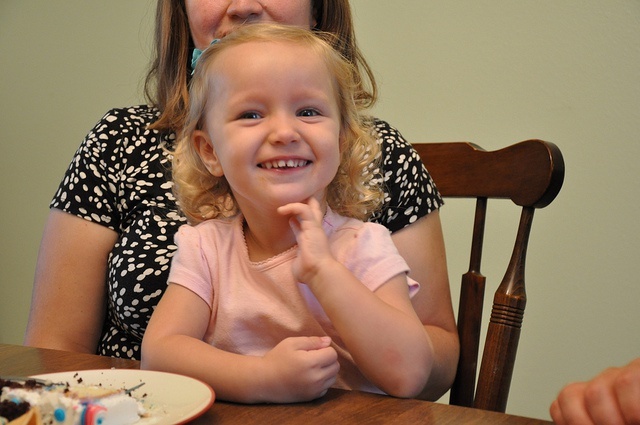Describe the objects in this image and their specific colors. I can see people in olive, brown, salmon, and tan tones, people in olive, black, gray, brown, and tan tones, chair in olive, black, maroon, and tan tones, dining table in olive, tan, maroon, and brown tones, and cake in olive, tan, and black tones in this image. 